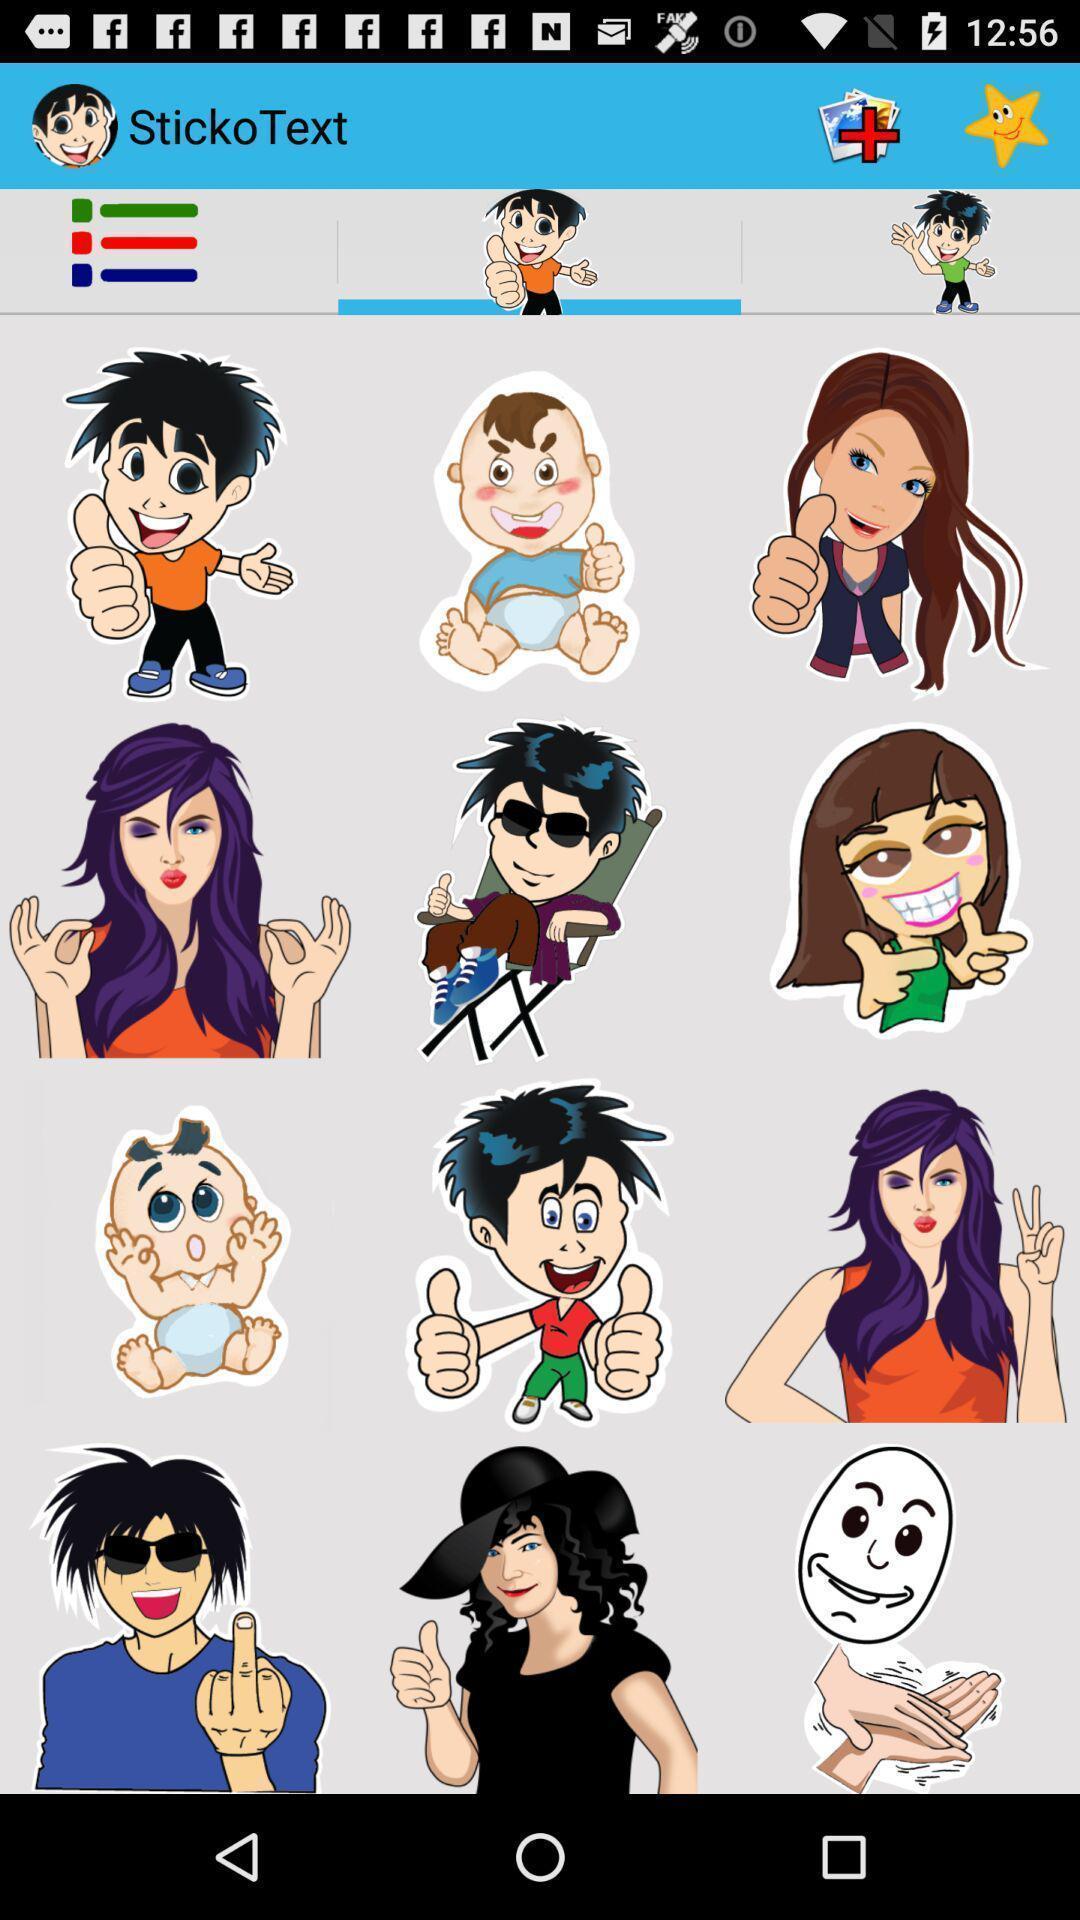Describe the visual elements of this screenshot. Screen displaying multiple different stickers. 